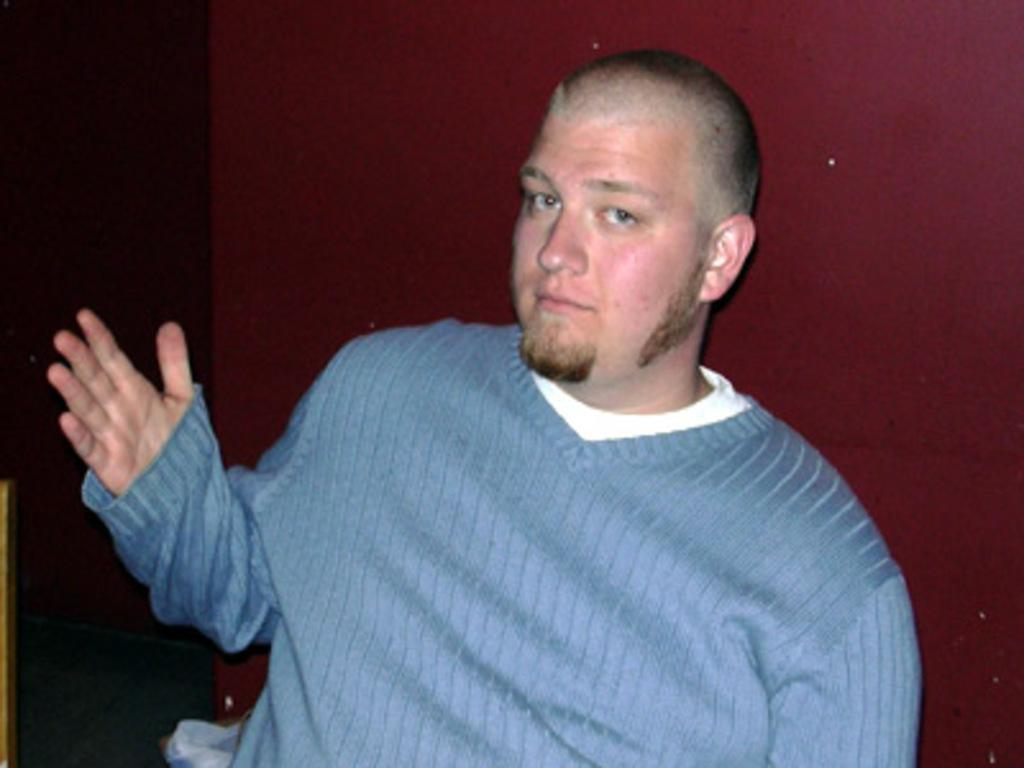Who is present in the image? There is a man in the image. What is the man wearing? The man is wearing a blue T-shirt. What can be seen in the background of the image? The background of the image appears to be maroon in color. What type of vein is visible on the man's arm in the image? There is no visible vein on the man's arm in the image. What type of metal can be seen in the background of the image? There is no metal visible in the background of the image. 